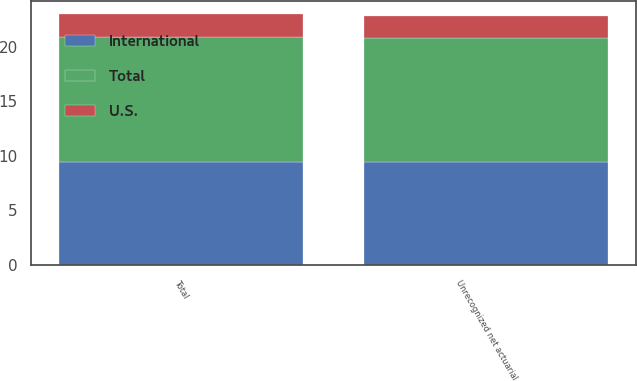Convert chart. <chart><loc_0><loc_0><loc_500><loc_500><stacked_bar_chart><ecel><fcel>Unrecognized net actuarial<fcel>Total<nl><fcel>U.S.<fcel>2<fcel>2.1<nl><fcel>International<fcel>9.4<fcel>9.4<nl><fcel>Total<fcel>11.4<fcel>11.5<nl></chart> 